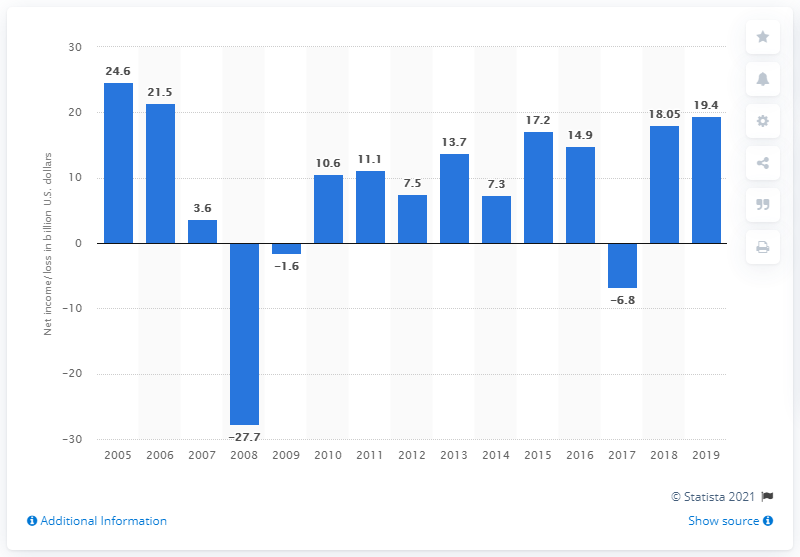Indicate a few pertinent items in this graphic. In 2019, Citigroup's net income was 19.4 billion dollars. 